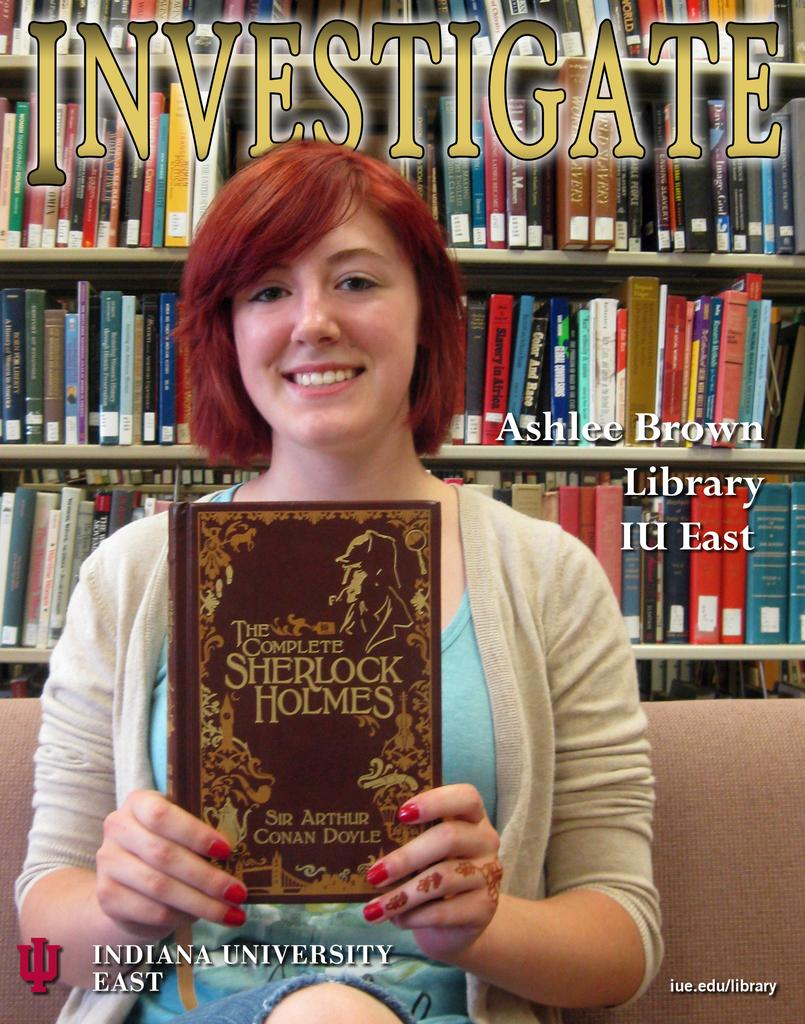<image>
Summarize the visual content of the image. A woman holds up a book of Sherlock Holmes stories. 